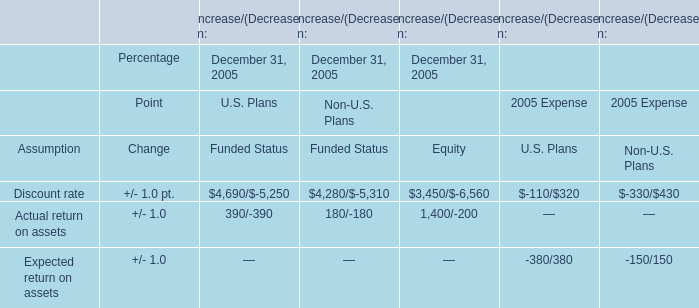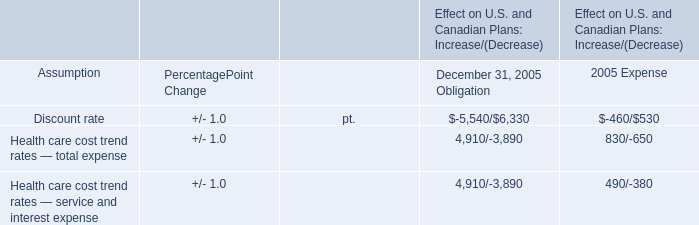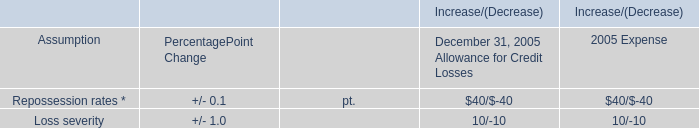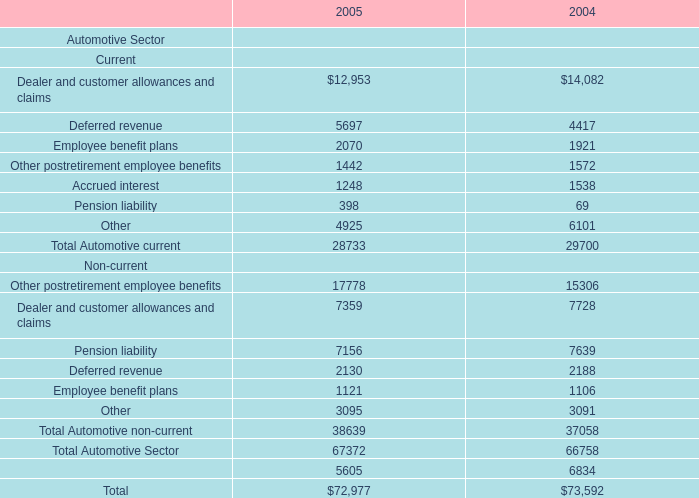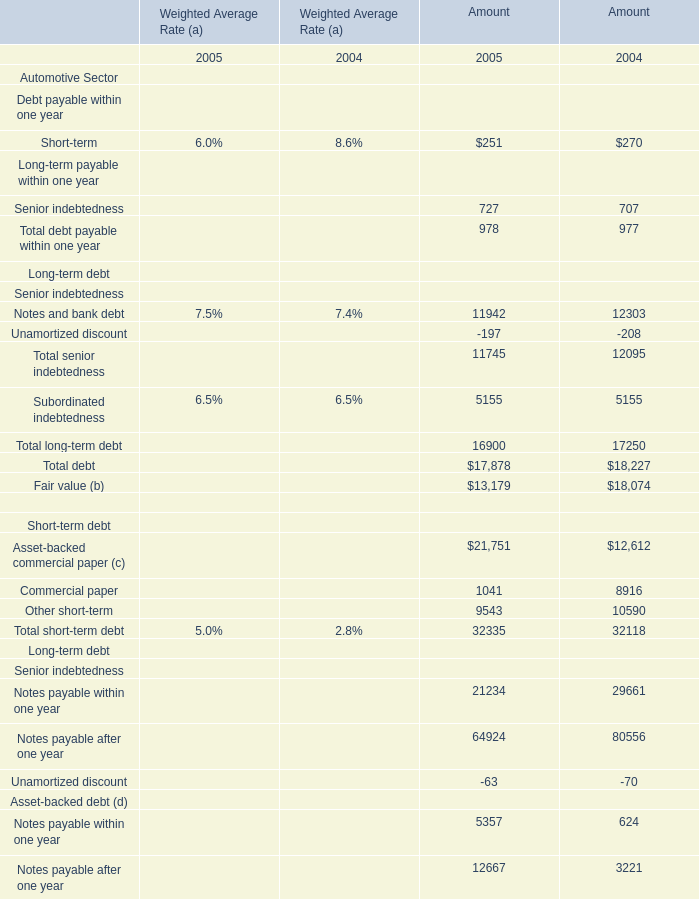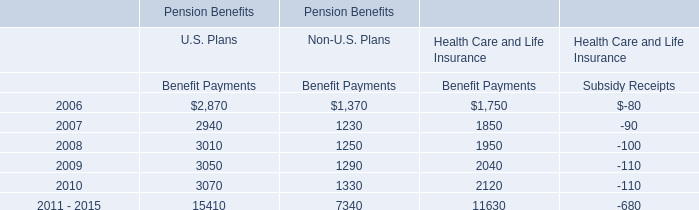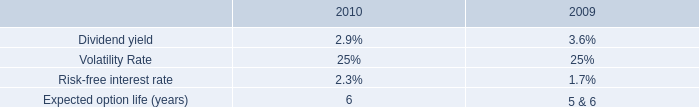What is the sum of Notes payable within one year,Notes payable after one year and Unamortized discount of Senior indebtedness in 2005 for Amount ? 
Computations: ((21234 + 64924) - 63)
Answer: 86095.0. 